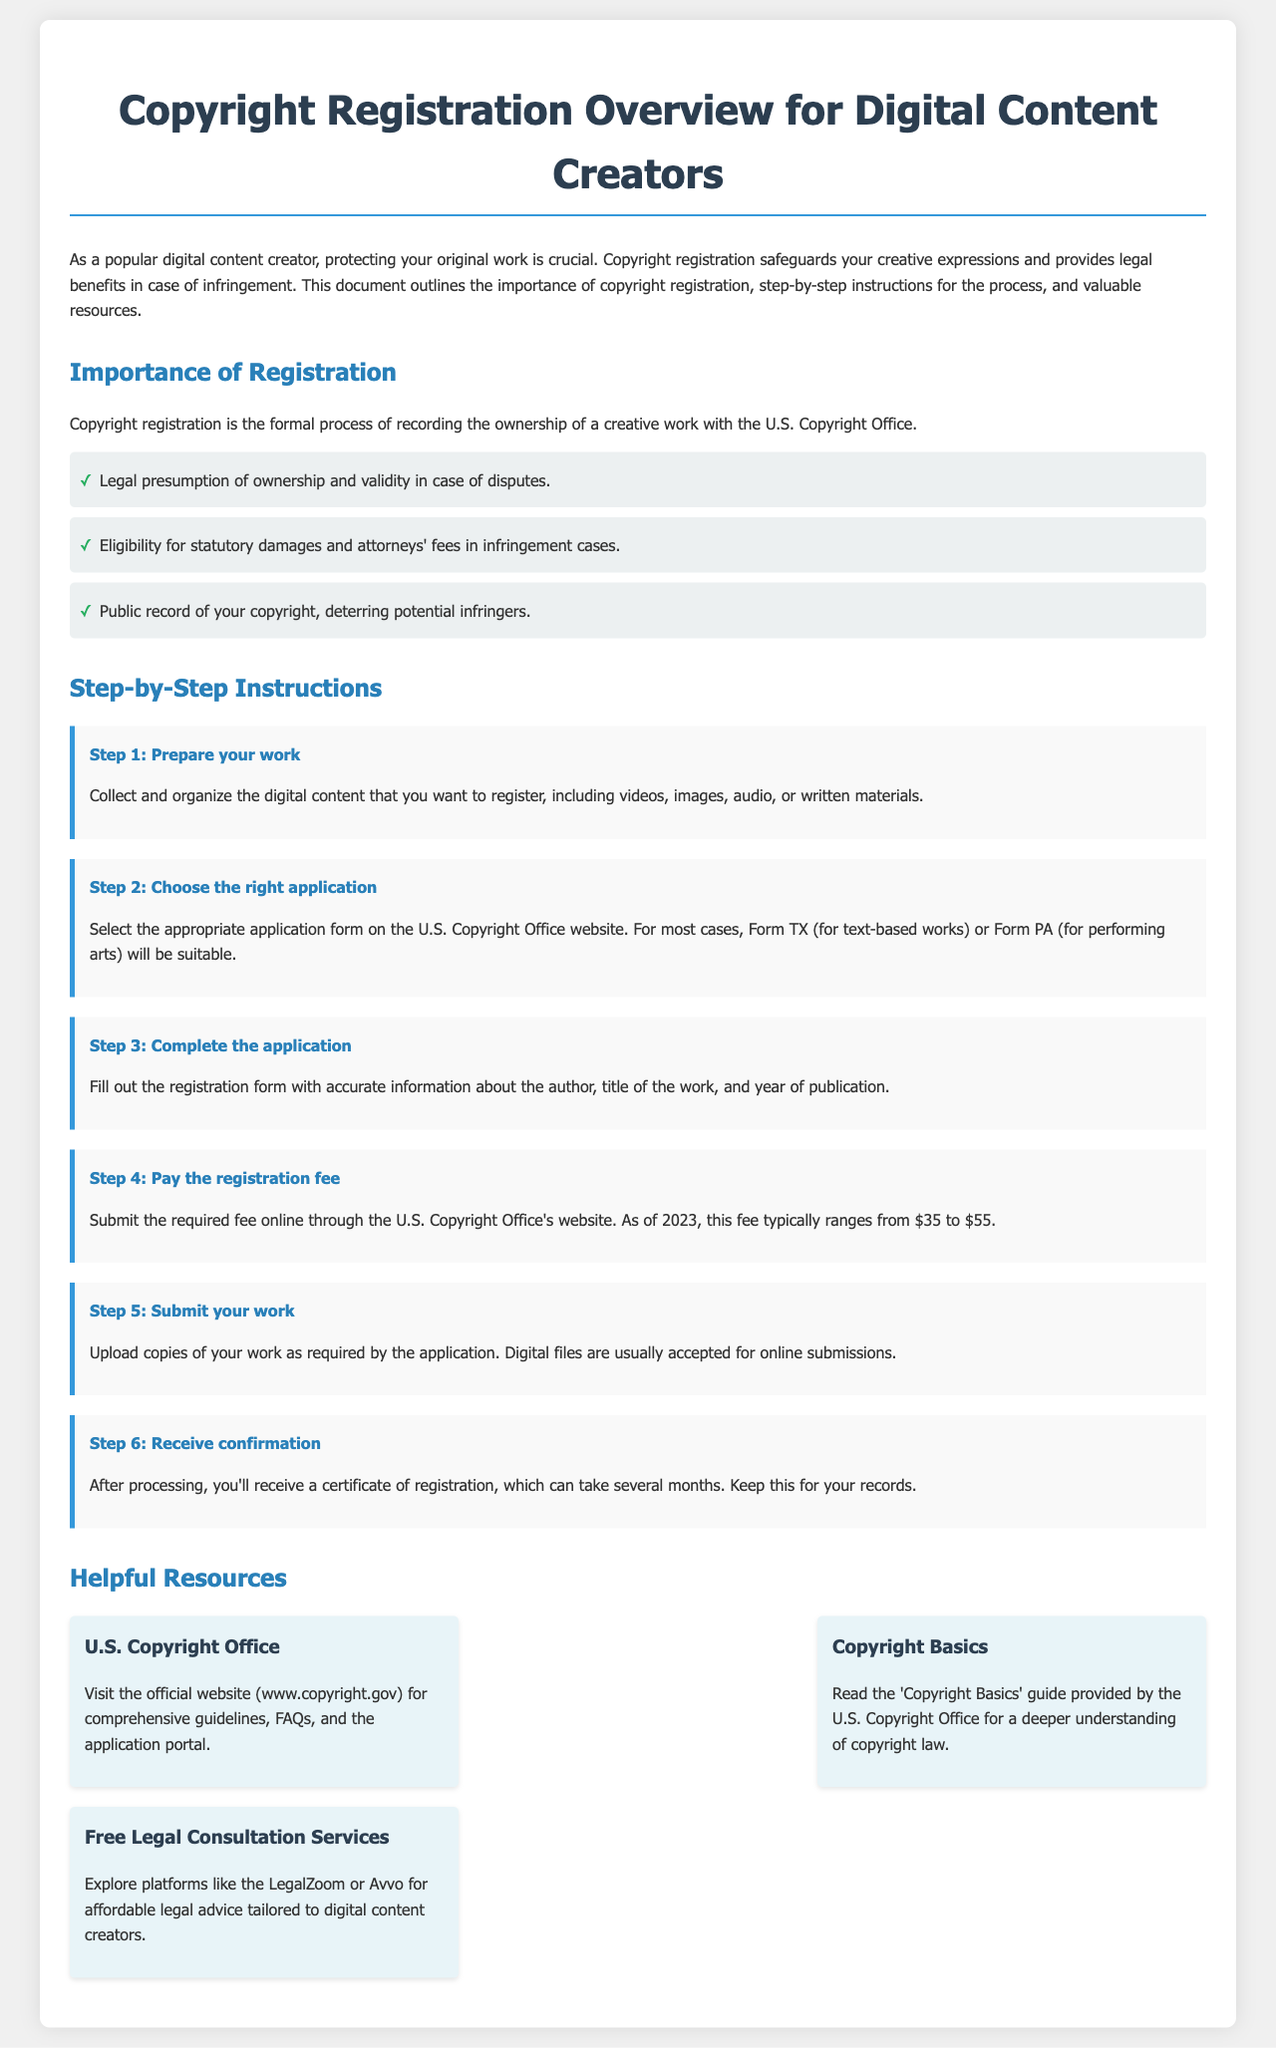What is the purpose of copyright registration? The document states that copyright registration safeguards your creative expressions and provides legal benefits in case of infringement.
Answer: Protecting original work What is the fee range for registration as of 2023? The document mentions that the registration fee typically ranges from $35 to $55.
Answer: $35 to $55 What is the first step in the registration process? According to the document, the first step is to collect and organize the digital content that you want to register.
Answer: Prepare your work Which application form is suitable for text-based works? The document specifies that Form TX is suitable for text-based works.
Answer: Form TX What should you do after submitting your work? The document states that after processing, you'll receive a certificate of registration.
Answer: Receive confirmation What website can you visit for comprehensive guidelines on copyright? The document indicates that the official website to visit is www.copyright.gov.
Answer: www.copyright.gov What benefit does registration provide in case of disputes? The document explains that registration gives a legal presumption of ownership and validity in case of disputes.
Answer: Legal presumption of ownership Name a platform where digital content creators can seek legal advice. The document lists LegalZoom as a platform for affordable legal advice tailored to digital content creators.
Answer: LegalZoom 